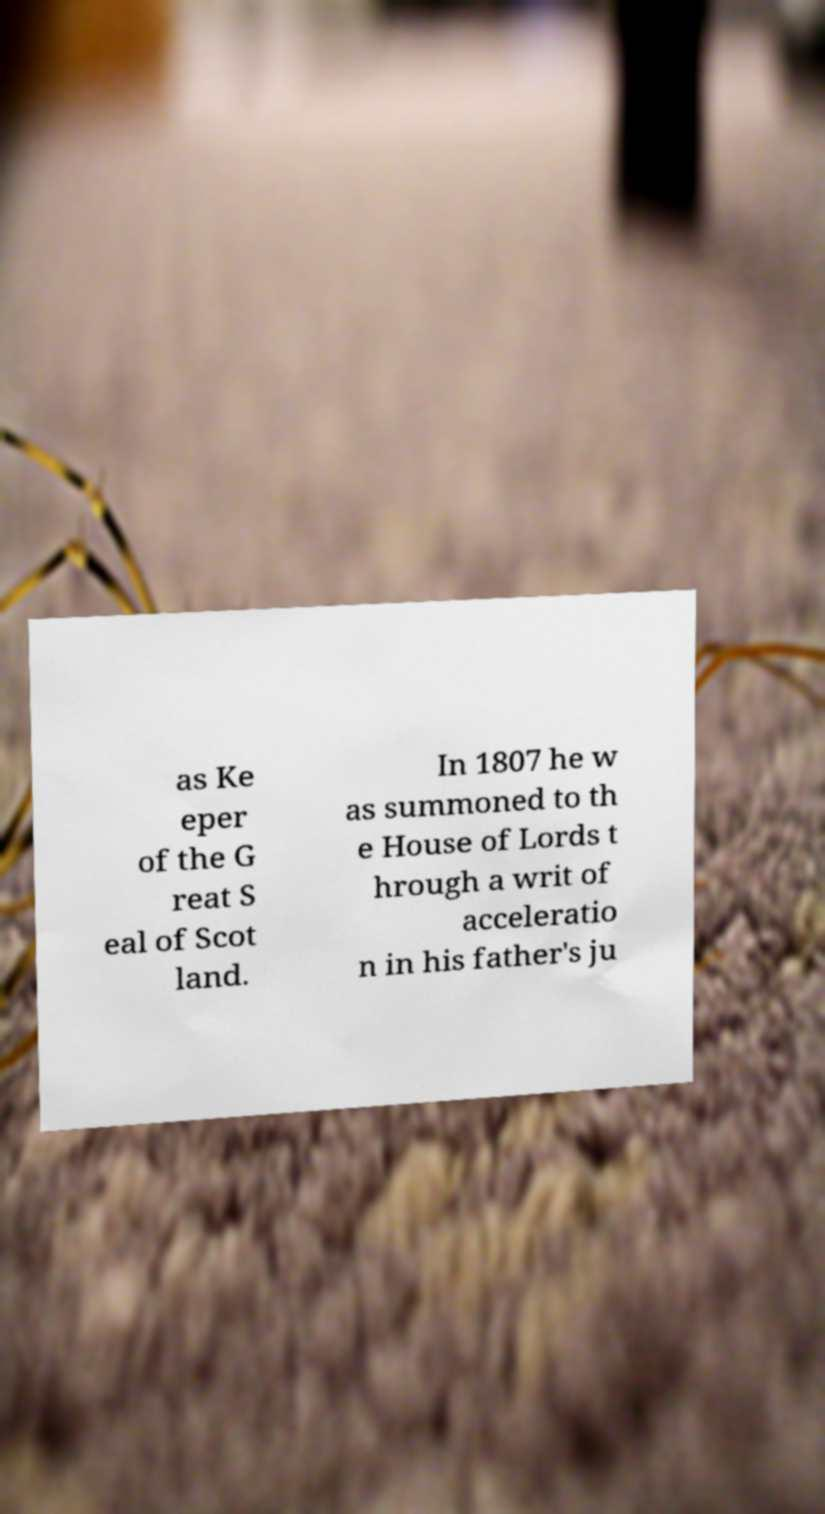Can you accurately transcribe the text from the provided image for me? as Ke eper of the G reat S eal of Scot land. In 1807 he w as summoned to th e House of Lords t hrough a writ of acceleratio n in his father's ju 